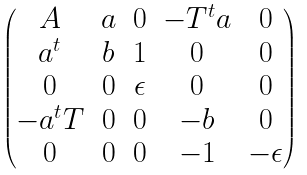Convert formula to latex. <formula><loc_0><loc_0><loc_500><loc_500>\begin{pmatrix} A & a & 0 & - T ^ { t } a & 0 \\ a ^ { t } & b & 1 & 0 & 0 \\ 0 & 0 & \epsilon & 0 & 0 \\ - a ^ { t } T & 0 & 0 & - b & 0 \\ 0 & 0 & 0 & - 1 & - \epsilon \end{pmatrix}</formula> 